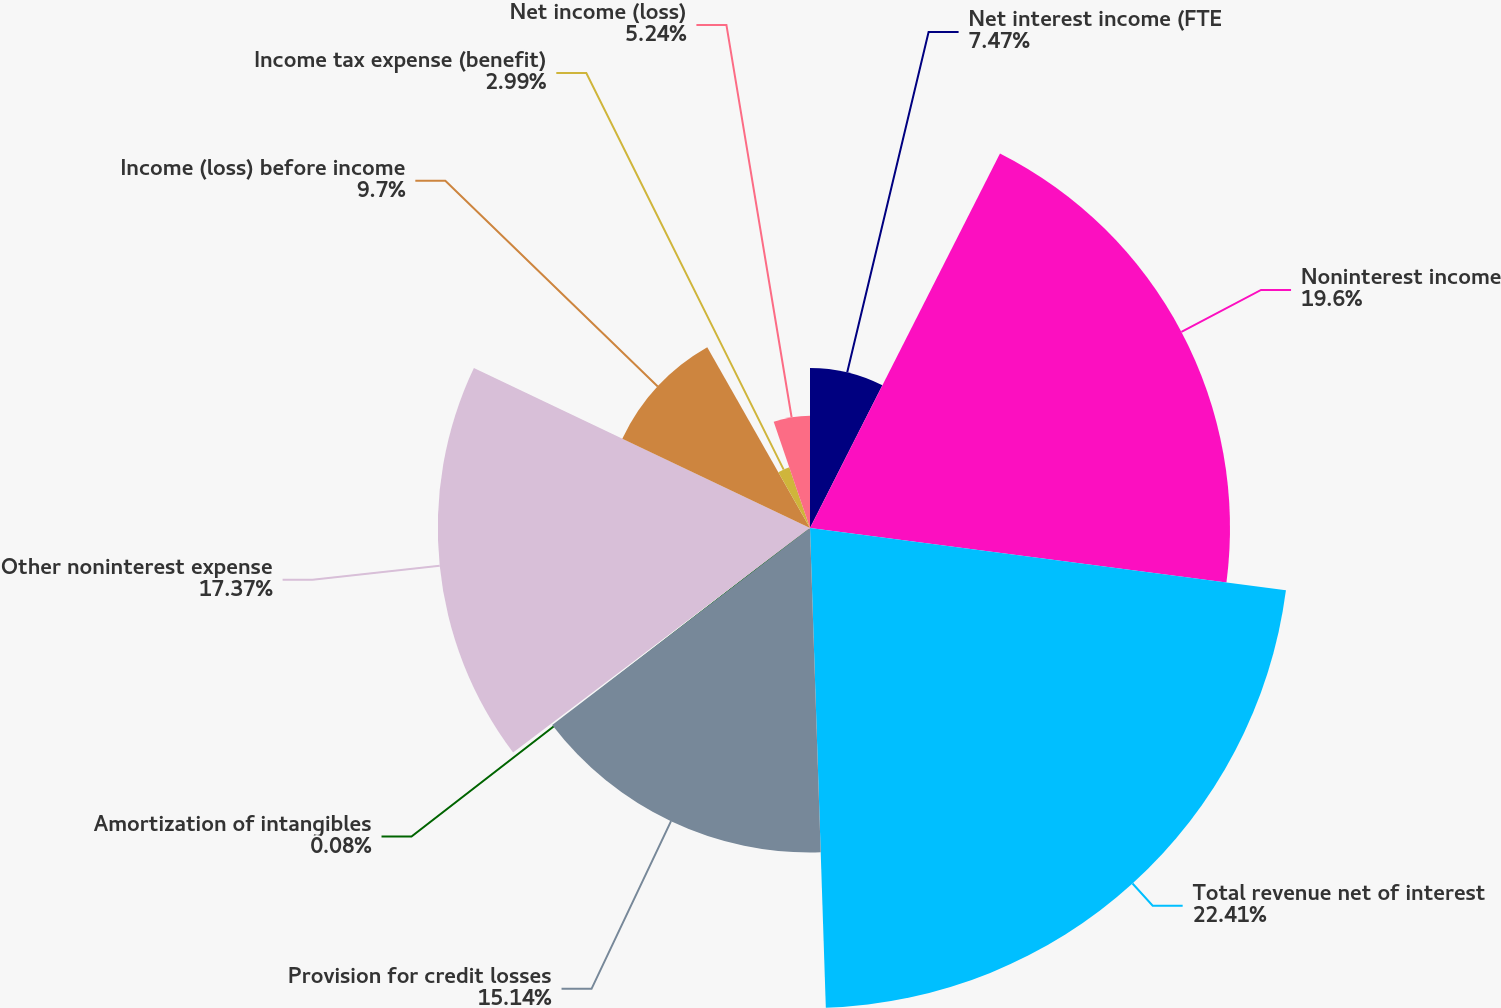<chart> <loc_0><loc_0><loc_500><loc_500><pie_chart><fcel>Net interest income (FTE<fcel>Noninterest income<fcel>Total revenue net of interest<fcel>Provision for credit losses<fcel>Amortization of intangibles<fcel>Other noninterest expense<fcel>Income (loss) before income<fcel>Income tax expense (benefit)<fcel>Net income (loss)<nl><fcel>7.47%<fcel>19.6%<fcel>22.4%<fcel>15.14%<fcel>0.08%<fcel>17.37%<fcel>9.7%<fcel>2.99%<fcel>5.24%<nl></chart> 